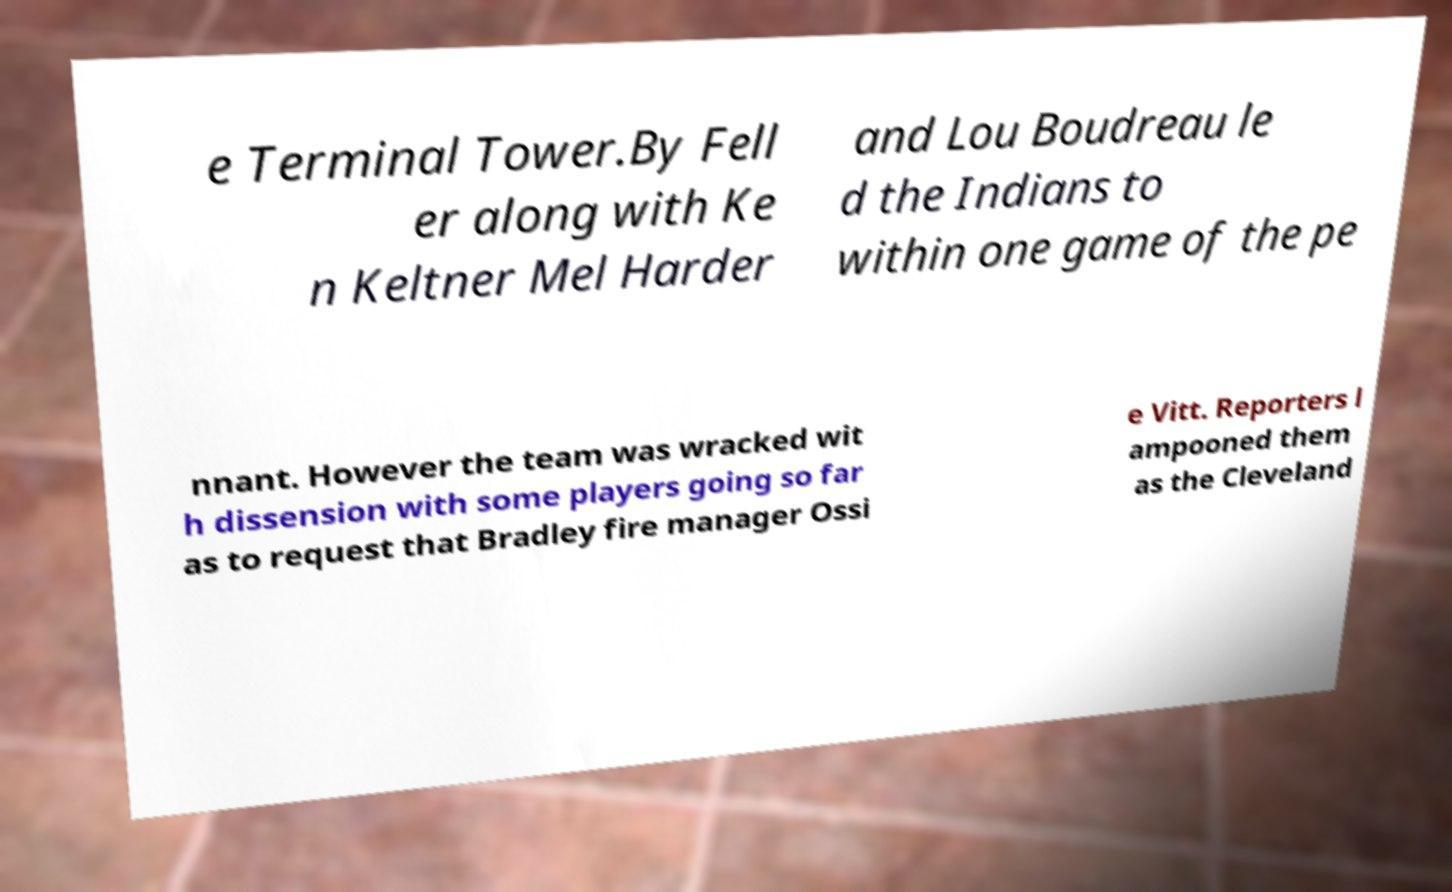Could you extract and type out the text from this image? e Terminal Tower.By Fell er along with Ke n Keltner Mel Harder and Lou Boudreau le d the Indians to within one game of the pe nnant. However the team was wracked wit h dissension with some players going so far as to request that Bradley fire manager Ossi e Vitt. Reporters l ampooned them as the Cleveland 